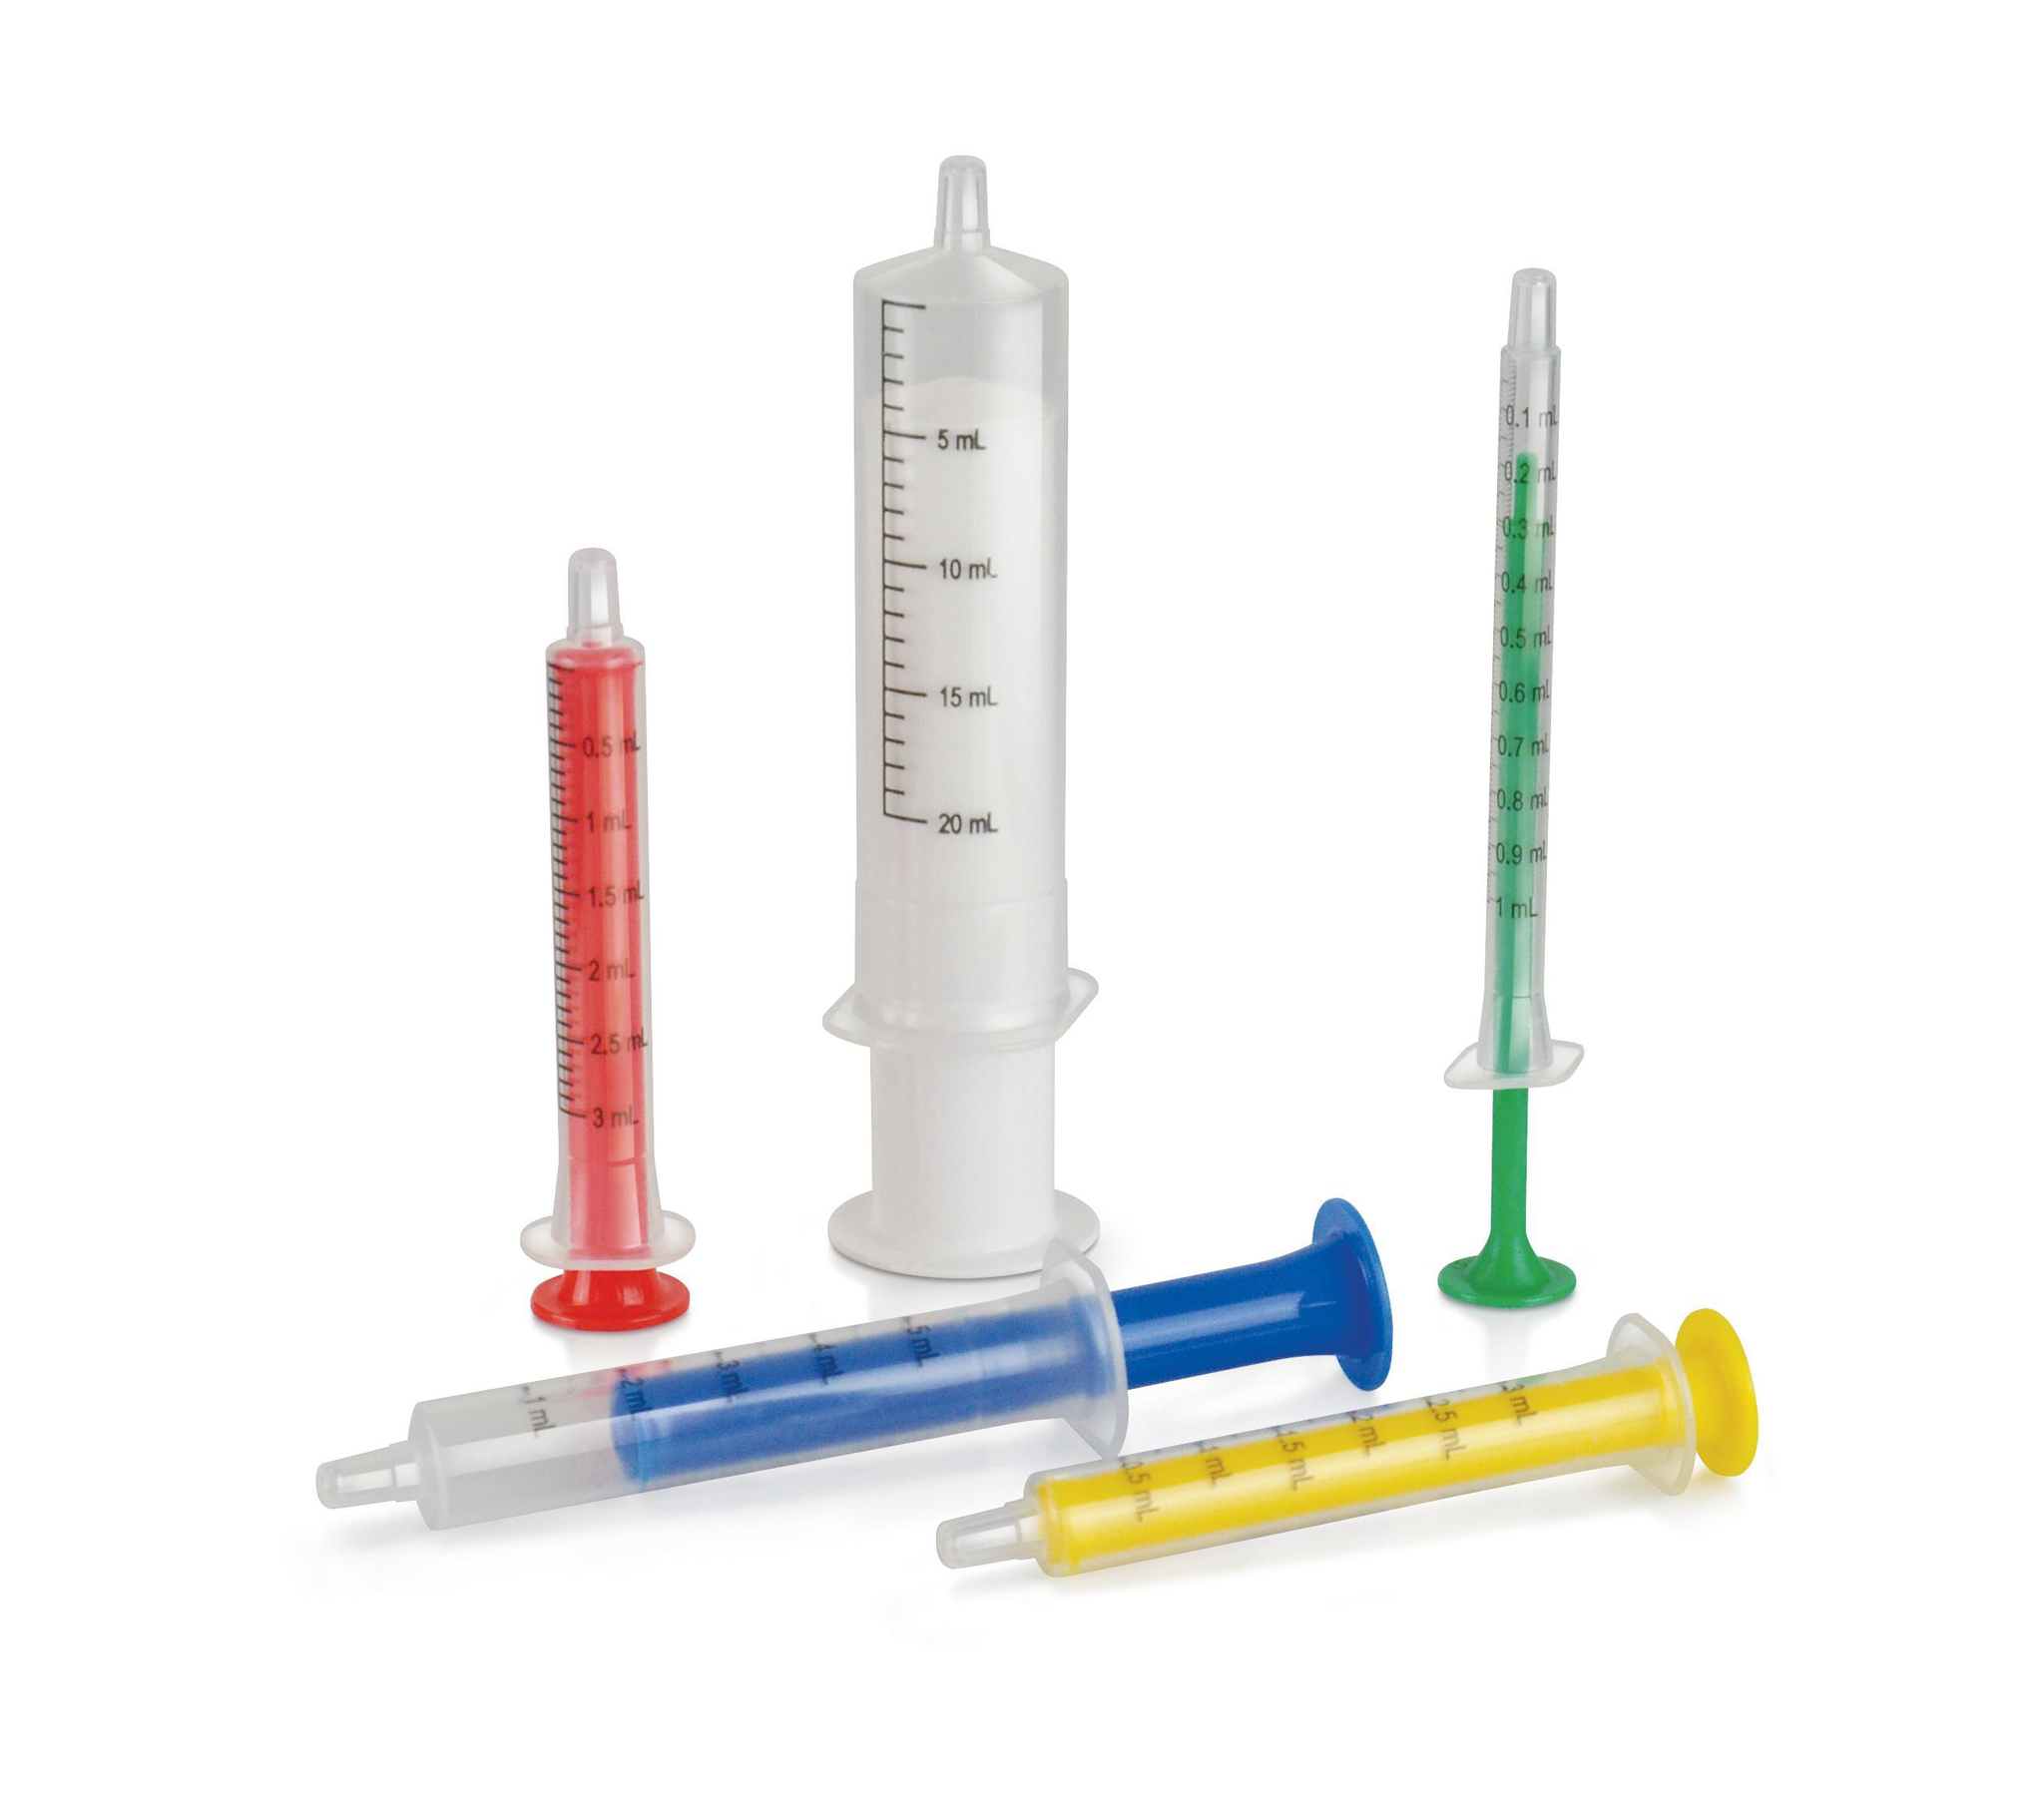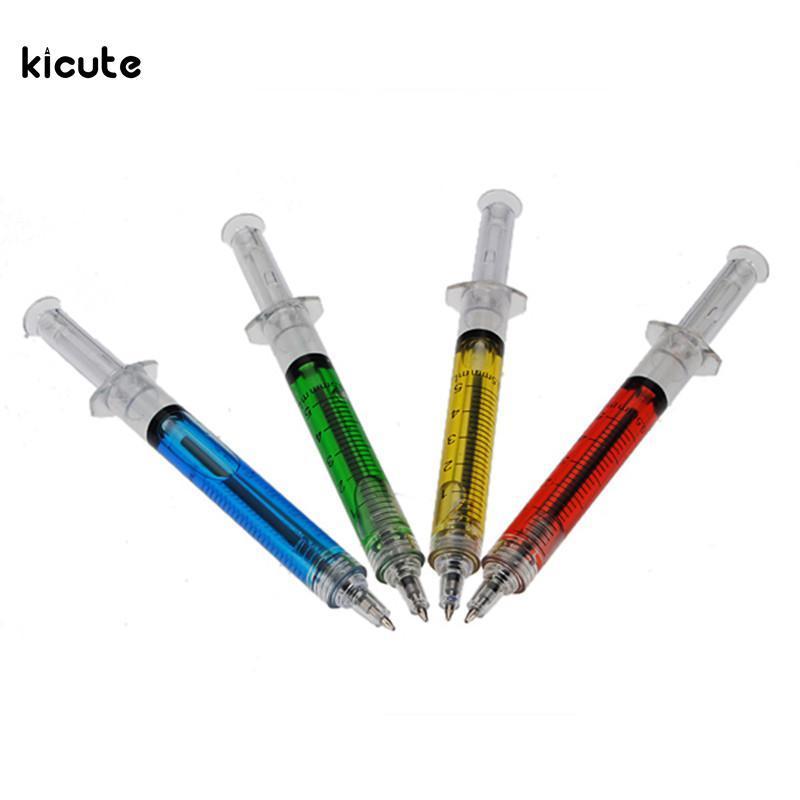The first image is the image on the left, the second image is the image on the right. Assess this claim about the two images: "The syringe in the right image furthest to the right has a red substance inside it.". Correct or not? Answer yes or no. Yes. The first image is the image on the left, the second image is the image on the right. For the images shown, is this caption "An image includes exactly three syringes displayed side-by-side at the same diagonal angle." true? Answer yes or no. No. 